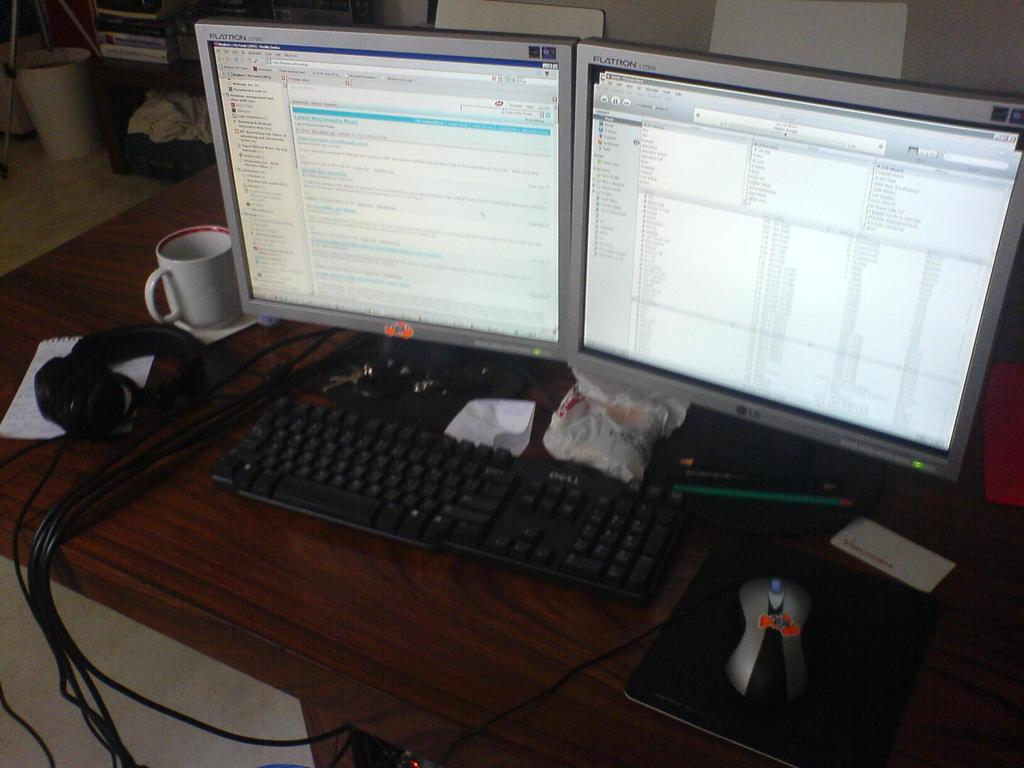<image>
Describe the image concisely. A keyboard with two monitors in front next to a mouse with a 2036 sticker. 